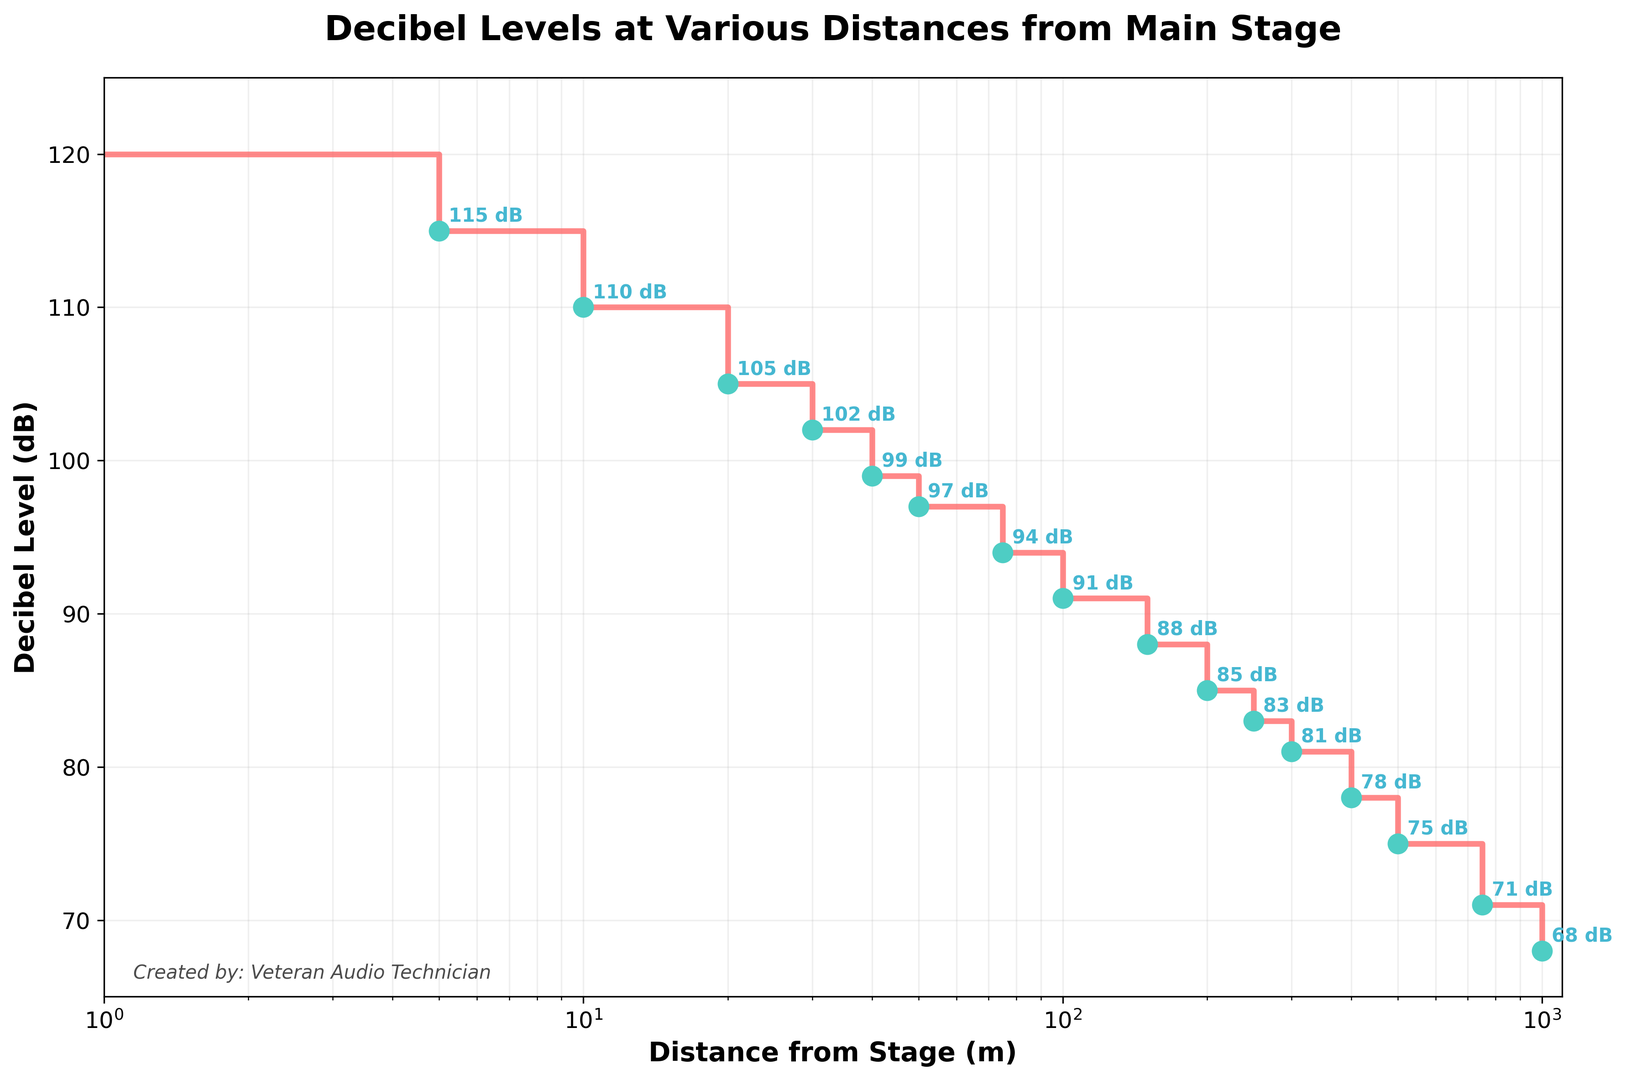How does the decibel level change from 10 meters to 50 meters from the stage? From 10 meters to 50 meters, the decibel level decreases from 110 dB to 97 dB. This involves a drop by 13 dB over that distance.
Answer: 13 dB At what distance from the stage does the decibel level first drop below 100 dB? By examining the distance and decibel values, the decibel level first drops below 100 dB at 30 meters, where it is 99 dB.
Answer: 30 meters What is the average decibel level between 200 meters and 500 meters from the stage? The decibel levels between 200 meters and 500 meters are 85 dB, 83 dB, 81 dB, and 78 dB. The sum of these values is 85 + 83 + 81 + 78 = 327 dB. There are 4 values, so the average is 327 / 4 = 81.75 dB.
Answer: 81.75 dB Which segment records the steepest decline in decibel levels, and what is the decline? To find the steepest decline, compare the drops in dB values over each of the intervals. The steepest decline is between 0 meters and 10 meters where the decibel level drops from 120 dB to 110 dB, a decline of 10 dB.
Answer: 10 dB from 0 to 10 meters Is the decibel level at 1000 meters less than half of the decibel level at 0 meters? The decibel level at 0 meters is 120 dB. Half of this is 60 dB. At 1000 meters, the decibel level is 68 dB, which is greater than 60 dB.
Answer: No Which distance from the stage corresponds to a decibel level of 75 dB? By looking at the plotted points, the decibel level of 75 dB occurs at 500 meters from the stage.
Answer: 500 meters What's the difference in decibel levels between the distances of 5 meters and 100 meters from the stage? The decibel levels at 5 meters and 100 meters are 115 dB and 91 dB, respectively. The difference is 115 - 91 = 24 dB.
Answer: 24 dB What trend do you observe in the decibel levels as the distance from the stage increases? The decibel level consistently decreases as the distance from the stage increases, illustrating that sound intensity drops with increasing distance. This is evident from the step-like decline in the graph.
Answer: Decreases What is the longest distance from the stage where the decibel level stays above 90 dB? Examining the data points, the decibel level is 91 dB at 100 meters. Beyond this point, it drops below 90 dB.
Answer: 100 meters 